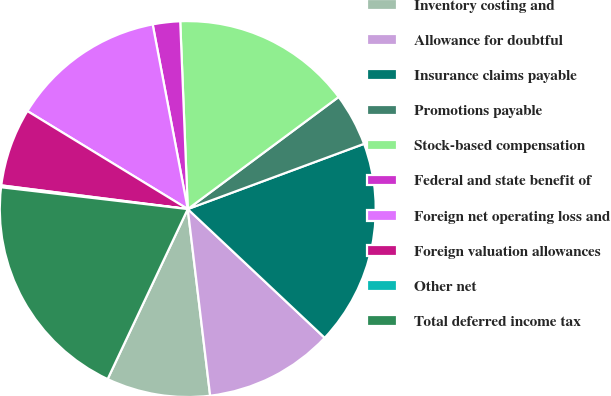Convert chart to OTSL. <chart><loc_0><loc_0><loc_500><loc_500><pie_chart><fcel>Inventory costing and<fcel>Allowance for doubtful<fcel>Insurance claims payable<fcel>Promotions payable<fcel>Stock-based compensation<fcel>Federal and state benefit of<fcel>Foreign net operating loss and<fcel>Foreign valuation allowances<fcel>Other net<fcel>Total deferred income tax<nl><fcel>8.91%<fcel>11.09%<fcel>17.65%<fcel>4.53%<fcel>15.47%<fcel>2.35%<fcel>13.28%<fcel>6.72%<fcel>0.16%<fcel>19.84%<nl></chart> 